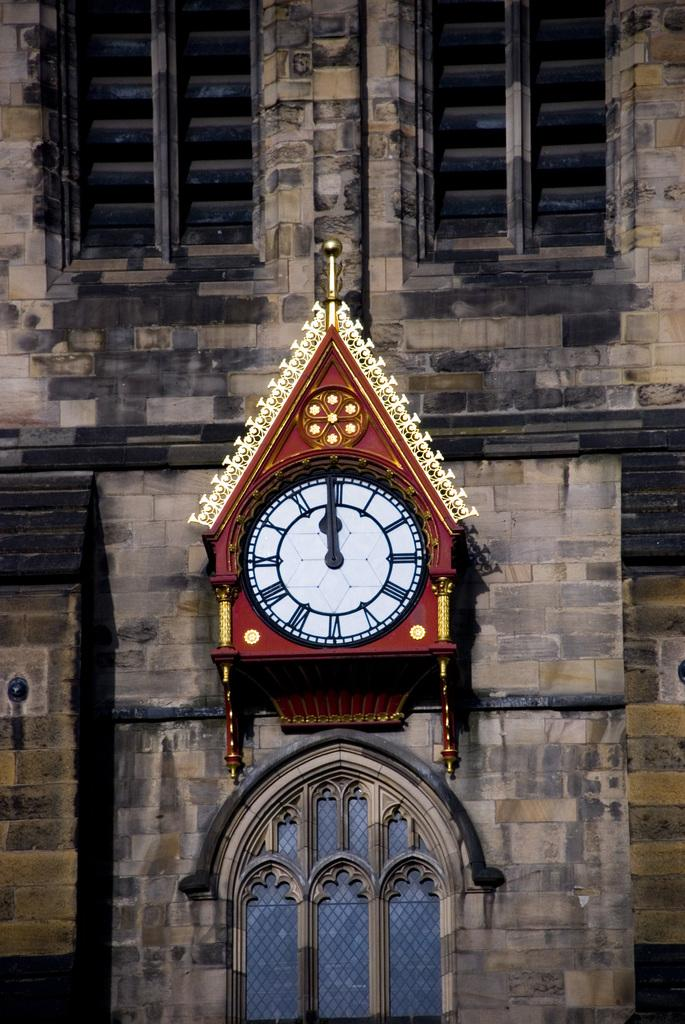<image>
Create a compact narrative representing the image presented. Clock on top of a window with the hands on the number 12. 